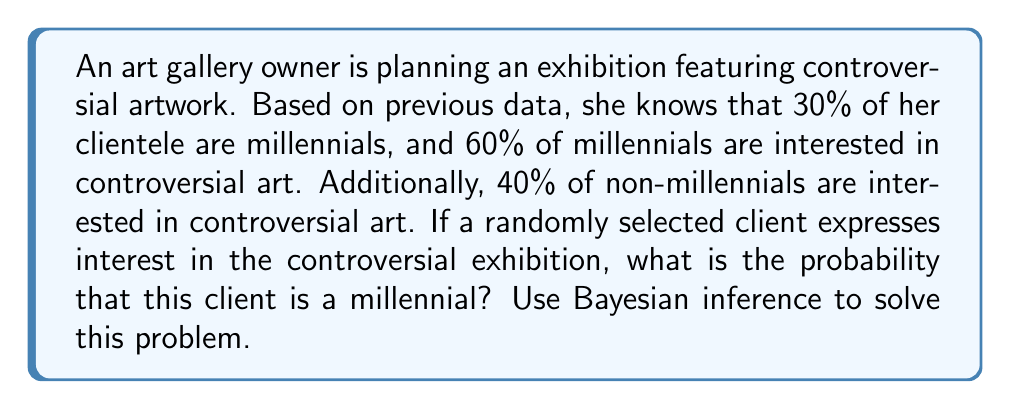Help me with this question. Let's approach this problem using Bayesian inference:

1) Define our events:
   A: The client is a millennial
   B: The client is interested in controversial art

2) Given probabilities:
   P(A) = 0.30 (prior probability of being a millennial)
   P(B|A) = 0.60 (probability of interest given millennial)
   P(B|not A) = 0.40 (probability of interest given non-millennial)

3) We want to find P(A|B) using Bayes' theorem:

   $$P(A|B) = \frac{P(B|A) \cdot P(A)}{P(B)}$$

4) Calculate P(B) using the law of total probability:
   
   $$P(B) = P(B|A) \cdot P(A) + P(B|not A) \cdot P(not A)$$
   $$P(B) = 0.60 \cdot 0.30 + 0.40 \cdot 0.70 = 0.18 + 0.28 = 0.46$$

5) Now we can apply Bayes' theorem:

   $$P(A|B) = \frac{0.60 \cdot 0.30}{0.46} = \frac{0.18}{0.46} \approx 0.3913$$

6) Convert to a percentage: 0.3913 * 100% ≈ 39.13%

Therefore, if a randomly selected client expresses interest in the controversial exhibition, there is approximately a 39.13% chance that this client is a millennial.
Answer: 39.13% 